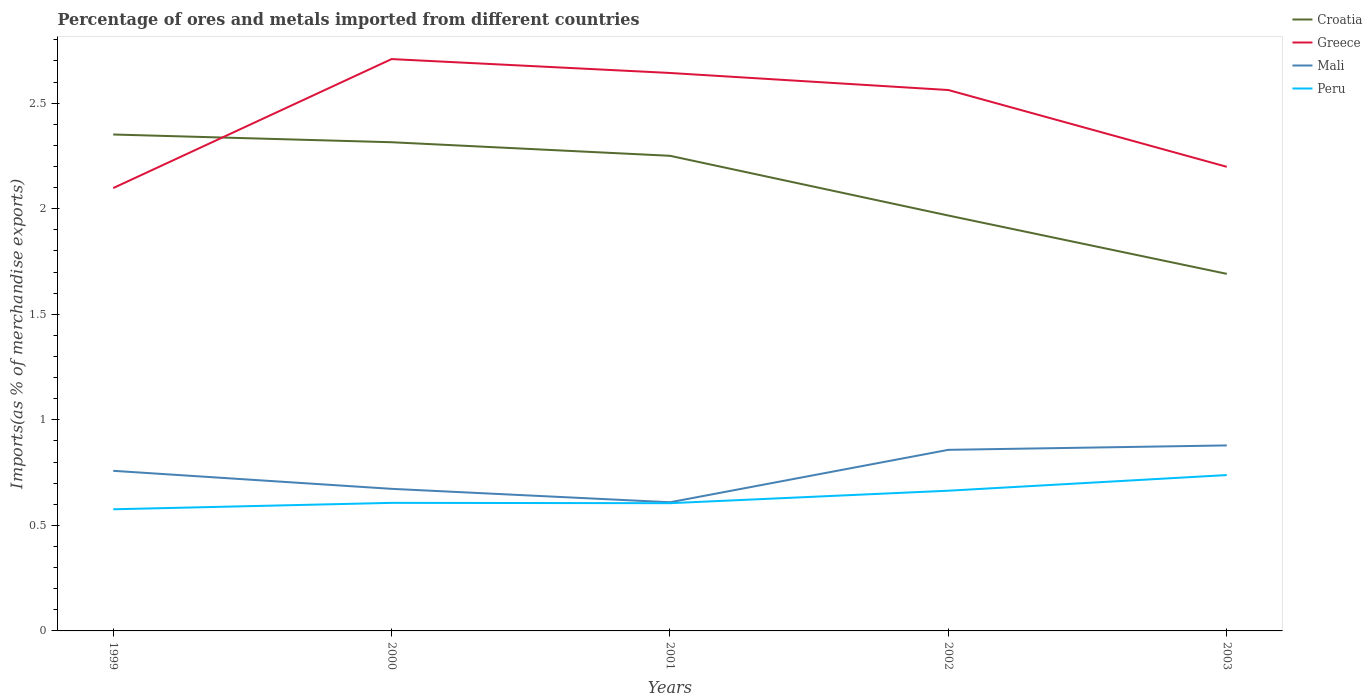Does the line corresponding to Peru intersect with the line corresponding to Mali?
Your answer should be very brief. No. Is the number of lines equal to the number of legend labels?
Make the answer very short. Yes. Across all years, what is the maximum percentage of imports to different countries in Croatia?
Provide a succinct answer. 1.69. In which year was the percentage of imports to different countries in Greece maximum?
Your response must be concise. 1999. What is the total percentage of imports to different countries in Croatia in the graph?
Provide a short and direct response. 0.56. What is the difference between the highest and the second highest percentage of imports to different countries in Mali?
Your response must be concise. 0.27. What is the difference between the highest and the lowest percentage of imports to different countries in Peru?
Offer a very short reply. 2. What is the difference between two consecutive major ticks on the Y-axis?
Ensure brevity in your answer.  0.5. Does the graph contain grids?
Ensure brevity in your answer.  No. How many legend labels are there?
Offer a very short reply. 4. What is the title of the graph?
Provide a succinct answer. Percentage of ores and metals imported from different countries. What is the label or title of the Y-axis?
Provide a succinct answer. Imports(as % of merchandise exports). What is the Imports(as % of merchandise exports) in Croatia in 1999?
Offer a terse response. 2.35. What is the Imports(as % of merchandise exports) of Greece in 1999?
Offer a terse response. 2.1. What is the Imports(as % of merchandise exports) in Mali in 1999?
Your answer should be very brief. 0.76. What is the Imports(as % of merchandise exports) in Peru in 1999?
Provide a succinct answer. 0.58. What is the Imports(as % of merchandise exports) in Croatia in 2000?
Offer a terse response. 2.32. What is the Imports(as % of merchandise exports) of Greece in 2000?
Your answer should be compact. 2.71. What is the Imports(as % of merchandise exports) of Mali in 2000?
Give a very brief answer. 0.67. What is the Imports(as % of merchandise exports) of Peru in 2000?
Your answer should be compact. 0.61. What is the Imports(as % of merchandise exports) in Croatia in 2001?
Provide a succinct answer. 2.25. What is the Imports(as % of merchandise exports) in Greece in 2001?
Your response must be concise. 2.64. What is the Imports(as % of merchandise exports) in Mali in 2001?
Give a very brief answer. 0.61. What is the Imports(as % of merchandise exports) of Peru in 2001?
Your answer should be compact. 0.61. What is the Imports(as % of merchandise exports) of Croatia in 2002?
Give a very brief answer. 1.97. What is the Imports(as % of merchandise exports) of Greece in 2002?
Make the answer very short. 2.56. What is the Imports(as % of merchandise exports) in Mali in 2002?
Offer a terse response. 0.86. What is the Imports(as % of merchandise exports) of Peru in 2002?
Make the answer very short. 0.66. What is the Imports(as % of merchandise exports) of Croatia in 2003?
Your answer should be compact. 1.69. What is the Imports(as % of merchandise exports) in Greece in 2003?
Keep it short and to the point. 2.2. What is the Imports(as % of merchandise exports) in Mali in 2003?
Keep it short and to the point. 0.88. What is the Imports(as % of merchandise exports) of Peru in 2003?
Give a very brief answer. 0.74. Across all years, what is the maximum Imports(as % of merchandise exports) in Croatia?
Your answer should be very brief. 2.35. Across all years, what is the maximum Imports(as % of merchandise exports) in Greece?
Your answer should be compact. 2.71. Across all years, what is the maximum Imports(as % of merchandise exports) in Mali?
Provide a short and direct response. 0.88. Across all years, what is the maximum Imports(as % of merchandise exports) of Peru?
Give a very brief answer. 0.74. Across all years, what is the minimum Imports(as % of merchandise exports) in Croatia?
Your answer should be compact. 1.69. Across all years, what is the minimum Imports(as % of merchandise exports) of Greece?
Your answer should be very brief. 2.1. Across all years, what is the minimum Imports(as % of merchandise exports) in Mali?
Provide a short and direct response. 0.61. Across all years, what is the minimum Imports(as % of merchandise exports) in Peru?
Your answer should be compact. 0.58. What is the total Imports(as % of merchandise exports) of Croatia in the graph?
Offer a terse response. 10.58. What is the total Imports(as % of merchandise exports) of Greece in the graph?
Provide a succinct answer. 12.21. What is the total Imports(as % of merchandise exports) of Mali in the graph?
Provide a short and direct response. 3.78. What is the total Imports(as % of merchandise exports) in Peru in the graph?
Your response must be concise. 3.19. What is the difference between the Imports(as % of merchandise exports) of Croatia in 1999 and that in 2000?
Your response must be concise. 0.04. What is the difference between the Imports(as % of merchandise exports) of Greece in 1999 and that in 2000?
Provide a short and direct response. -0.61. What is the difference between the Imports(as % of merchandise exports) in Mali in 1999 and that in 2000?
Provide a succinct answer. 0.09. What is the difference between the Imports(as % of merchandise exports) in Peru in 1999 and that in 2000?
Make the answer very short. -0.03. What is the difference between the Imports(as % of merchandise exports) of Croatia in 1999 and that in 2001?
Provide a short and direct response. 0.1. What is the difference between the Imports(as % of merchandise exports) in Greece in 1999 and that in 2001?
Ensure brevity in your answer.  -0.55. What is the difference between the Imports(as % of merchandise exports) in Mali in 1999 and that in 2001?
Offer a terse response. 0.15. What is the difference between the Imports(as % of merchandise exports) of Peru in 1999 and that in 2001?
Give a very brief answer. -0.03. What is the difference between the Imports(as % of merchandise exports) in Croatia in 1999 and that in 2002?
Your response must be concise. 0.38. What is the difference between the Imports(as % of merchandise exports) of Greece in 1999 and that in 2002?
Provide a short and direct response. -0.46. What is the difference between the Imports(as % of merchandise exports) of Mali in 1999 and that in 2002?
Offer a very short reply. -0.1. What is the difference between the Imports(as % of merchandise exports) of Peru in 1999 and that in 2002?
Your answer should be very brief. -0.09. What is the difference between the Imports(as % of merchandise exports) of Croatia in 1999 and that in 2003?
Offer a terse response. 0.66. What is the difference between the Imports(as % of merchandise exports) of Greece in 1999 and that in 2003?
Give a very brief answer. -0.1. What is the difference between the Imports(as % of merchandise exports) in Mali in 1999 and that in 2003?
Provide a short and direct response. -0.12. What is the difference between the Imports(as % of merchandise exports) in Peru in 1999 and that in 2003?
Give a very brief answer. -0.16. What is the difference between the Imports(as % of merchandise exports) of Croatia in 2000 and that in 2001?
Your answer should be very brief. 0.06. What is the difference between the Imports(as % of merchandise exports) of Greece in 2000 and that in 2001?
Your answer should be compact. 0.07. What is the difference between the Imports(as % of merchandise exports) of Mali in 2000 and that in 2001?
Give a very brief answer. 0.06. What is the difference between the Imports(as % of merchandise exports) in Peru in 2000 and that in 2001?
Offer a terse response. 0. What is the difference between the Imports(as % of merchandise exports) of Croatia in 2000 and that in 2002?
Your answer should be compact. 0.35. What is the difference between the Imports(as % of merchandise exports) of Greece in 2000 and that in 2002?
Offer a very short reply. 0.15. What is the difference between the Imports(as % of merchandise exports) in Mali in 2000 and that in 2002?
Your answer should be very brief. -0.18. What is the difference between the Imports(as % of merchandise exports) in Peru in 2000 and that in 2002?
Provide a succinct answer. -0.06. What is the difference between the Imports(as % of merchandise exports) of Croatia in 2000 and that in 2003?
Ensure brevity in your answer.  0.62. What is the difference between the Imports(as % of merchandise exports) of Greece in 2000 and that in 2003?
Your response must be concise. 0.51. What is the difference between the Imports(as % of merchandise exports) of Mali in 2000 and that in 2003?
Give a very brief answer. -0.21. What is the difference between the Imports(as % of merchandise exports) of Peru in 2000 and that in 2003?
Ensure brevity in your answer.  -0.13. What is the difference between the Imports(as % of merchandise exports) in Croatia in 2001 and that in 2002?
Make the answer very short. 0.28. What is the difference between the Imports(as % of merchandise exports) of Greece in 2001 and that in 2002?
Provide a short and direct response. 0.08. What is the difference between the Imports(as % of merchandise exports) in Mali in 2001 and that in 2002?
Provide a succinct answer. -0.25. What is the difference between the Imports(as % of merchandise exports) in Peru in 2001 and that in 2002?
Provide a succinct answer. -0.06. What is the difference between the Imports(as % of merchandise exports) of Croatia in 2001 and that in 2003?
Offer a terse response. 0.56. What is the difference between the Imports(as % of merchandise exports) in Greece in 2001 and that in 2003?
Your answer should be compact. 0.44. What is the difference between the Imports(as % of merchandise exports) in Mali in 2001 and that in 2003?
Offer a very short reply. -0.27. What is the difference between the Imports(as % of merchandise exports) in Peru in 2001 and that in 2003?
Your answer should be compact. -0.13. What is the difference between the Imports(as % of merchandise exports) of Croatia in 2002 and that in 2003?
Make the answer very short. 0.28. What is the difference between the Imports(as % of merchandise exports) of Greece in 2002 and that in 2003?
Your answer should be very brief. 0.36. What is the difference between the Imports(as % of merchandise exports) in Mali in 2002 and that in 2003?
Provide a succinct answer. -0.02. What is the difference between the Imports(as % of merchandise exports) in Peru in 2002 and that in 2003?
Offer a very short reply. -0.07. What is the difference between the Imports(as % of merchandise exports) of Croatia in 1999 and the Imports(as % of merchandise exports) of Greece in 2000?
Offer a very short reply. -0.36. What is the difference between the Imports(as % of merchandise exports) of Croatia in 1999 and the Imports(as % of merchandise exports) of Mali in 2000?
Your response must be concise. 1.68. What is the difference between the Imports(as % of merchandise exports) in Croatia in 1999 and the Imports(as % of merchandise exports) in Peru in 2000?
Make the answer very short. 1.75. What is the difference between the Imports(as % of merchandise exports) of Greece in 1999 and the Imports(as % of merchandise exports) of Mali in 2000?
Ensure brevity in your answer.  1.42. What is the difference between the Imports(as % of merchandise exports) of Greece in 1999 and the Imports(as % of merchandise exports) of Peru in 2000?
Your answer should be compact. 1.49. What is the difference between the Imports(as % of merchandise exports) of Mali in 1999 and the Imports(as % of merchandise exports) of Peru in 2000?
Offer a terse response. 0.15. What is the difference between the Imports(as % of merchandise exports) of Croatia in 1999 and the Imports(as % of merchandise exports) of Greece in 2001?
Make the answer very short. -0.29. What is the difference between the Imports(as % of merchandise exports) in Croatia in 1999 and the Imports(as % of merchandise exports) in Mali in 2001?
Make the answer very short. 1.74. What is the difference between the Imports(as % of merchandise exports) in Croatia in 1999 and the Imports(as % of merchandise exports) in Peru in 2001?
Give a very brief answer. 1.75. What is the difference between the Imports(as % of merchandise exports) of Greece in 1999 and the Imports(as % of merchandise exports) of Mali in 2001?
Offer a very short reply. 1.49. What is the difference between the Imports(as % of merchandise exports) in Greece in 1999 and the Imports(as % of merchandise exports) in Peru in 2001?
Provide a succinct answer. 1.49. What is the difference between the Imports(as % of merchandise exports) in Mali in 1999 and the Imports(as % of merchandise exports) in Peru in 2001?
Your answer should be very brief. 0.15. What is the difference between the Imports(as % of merchandise exports) in Croatia in 1999 and the Imports(as % of merchandise exports) in Greece in 2002?
Offer a terse response. -0.21. What is the difference between the Imports(as % of merchandise exports) of Croatia in 1999 and the Imports(as % of merchandise exports) of Mali in 2002?
Give a very brief answer. 1.49. What is the difference between the Imports(as % of merchandise exports) in Croatia in 1999 and the Imports(as % of merchandise exports) in Peru in 2002?
Your answer should be very brief. 1.69. What is the difference between the Imports(as % of merchandise exports) in Greece in 1999 and the Imports(as % of merchandise exports) in Mali in 2002?
Offer a terse response. 1.24. What is the difference between the Imports(as % of merchandise exports) in Greece in 1999 and the Imports(as % of merchandise exports) in Peru in 2002?
Give a very brief answer. 1.43. What is the difference between the Imports(as % of merchandise exports) of Mali in 1999 and the Imports(as % of merchandise exports) of Peru in 2002?
Your response must be concise. 0.09. What is the difference between the Imports(as % of merchandise exports) of Croatia in 1999 and the Imports(as % of merchandise exports) of Greece in 2003?
Give a very brief answer. 0.15. What is the difference between the Imports(as % of merchandise exports) of Croatia in 1999 and the Imports(as % of merchandise exports) of Mali in 2003?
Make the answer very short. 1.47. What is the difference between the Imports(as % of merchandise exports) of Croatia in 1999 and the Imports(as % of merchandise exports) of Peru in 2003?
Provide a short and direct response. 1.61. What is the difference between the Imports(as % of merchandise exports) in Greece in 1999 and the Imports(as % of merchandise exports) in Mali in 2003?
Ensure brevity in your answer.  1.22. What is the difference between the Imports(as % of merchandise exports) in Greece in 1999 and the Imports(as % of merchandise exports) in Peru in 2003?
Your answer should be compact. 1.36. What is the difference between the Imports(as % of merchandise exports) in Mali in 1999 and the Imports(as % of merchandise exports) in Peru in 2003?
Your answer should be very brief. 0.02. What is the difference between the Imports(as % of merchandise exports) of Croatia in 2000 and the Imports(as % of merchandise exports) of Greece in 2001?
Offer a terse response. -0.33. What is the difference between the Imports(as % of merchandise exports) in Croatia in 2000 and the Imports(as % of merchandise exports) in Mali in 2001?
Offer a very short reply. 1.71. What is the difference between the Imports(as % of merchandise exports) in Croatia in 2000 and the Imports(as % of merchandise exports) in Peru in 2001?
Your response must be concise. 1.71. What is the difference between the Imports(as % of merchandise exports) of Greece in 2000 and the Imports(as % of merchandise exports) of Mali in 2001?
Make the answer very short. 2.1. What is the difference between the Imports(as % of merchandise exports) of Greece in 2000 and the Imports(as % of merchandise exports) of Peru in 2001?
Make the answer very short. 2.1. What is the difference between the Imports(as % of merchandise exports) in Mali in 2000 and the Imports(as % of merchandise exports) in Peru in 2001?
Keep it short and to the point. 0.07. What is the difference between the Imports(as % of merchandise exports) of Croatia in 2000 and the Imports(as % of merchandise exports) of Greece in 2002?
Your response must be concise. -0.25. What is the difference between the Imports(as % of merchandise exports) of Croatia in 2000 and the Imports(as % of merchandise exports) of Mali in 2002?
Give a very brief answer. 1.46. What is the difference between the Imports(as % of merchandise exports) of Croatia in 2000 and the Imports(as % of merchandise exports) of Peru in 2002?
Offer a terse response. 1.65. What is the difference between the Imports(as % of merchandise exports) in Greece in 2000 and the Imports(as % of merchandise exports) in Mali in 2002?
Offer a very short reply. 1.85. What is the difference between the Imports(as % of merchandise exports) of Greece in 2000 and the Imports(as % of merchandise exports) of Peru in 2002?
Keep it short and to the point. 2.04. What is the difference between the Imports(as % of merchandise exports) of Mali in 2000 and the Imports(as % of merchandise exports) of Peru in 2002?
Make the answer very short. 0.01. What is the difference between the Imports(as % of merchandise exports) in Croatia in 2000 and the Imports(as % of merchandise exports) in Greece in 2003?
Provide a short and direct response. 0.12. What is the difference between the Imports(as % of merchandise exports) of Croatia in 2000 and the Imports(as % of merchandise exports) of Mali in 2003?
Ensure brevity in your answer.  1.44. What is the difference between the Imports(as % of merchandise exports) in Croatia in 2000 and the Imports(as % of merchandise exports) in Peru in 2003?
Your answer should be very brief. 1.58. What is the difference between the Imports(as % of merchandise exports) of Greece in 2000 and the Imports(as % of merchandise exports) of Mali in 2003?
Make the answer very short. 1.83. What is the difference between the Imports(as % of merchandise exports) in Greece in 2000 and the Imports(as % of merchandise exports) in Peru in 2003?
Your answer should be very brief. 1.97. What is the difference between the Imports(as % of merchandise exports) of Mali in 2000 and the Imports(as % of merchandise exports) of Peru in 2003?
Your response must be concise. -0.07. What is the difference between the Imports(as % of merchandise exports) of Croatia in 2001 and the Imports(as % of merchandise exports) of Greece in 2002?
Provide a short and direct response. -0.31. What is the difference between the Imports(as % of merchandise exports) in Croatia in 2001 and the Imports(as % of merchandise exports) in Mali in 2002?
Your answer should be compact. 1.39. What is the difference between the Imports(as % of merchandise exports) in Croatia in 2001 and the Imports(as % of merchandise exports) in Peru in 2002?
Give a very brief answer. 1.59. What is the difference between the Imports(as % of merchandise exports) in Greece in 2001 and the Imports(as % of merchandise exports) in Mali in 2002?
Provide a short and direct response. 1.79. What is the difference between the Imports(as % of merchandise exports) of Greece in 2001 and the Imports(as % of merchandise exports) of Peru in 2002?
Your answer should be very brief. 1.98. What is the difference between the Imports(as % of merchandise exports) in Mali in 2001 and the Imports(as % of merchandise exports) in Peru in 2002?
Offer a very short reply. -0.05. What is the difference between the Imports(as % of merchandise exports) in Croatia in 2001 and the Imports(as % of merchandise exports) in Greece in 2003?
Your answer should be compact. 0.05. What is the difference between the Imports(as % of merchandise exports) in Croatia in 2001 and the Imports(as % of merchandise exports) in Mali in 2003?
Give a very brief answer. 1.37. What is the difference between the Imports(as % of merchandise exports) of Croatia in 2001 and the Imports(as % of merchandise exports) of Peru in 2003?
Your answer should be compact. 1.51. What is the difference between the Imports(as % of merchandise exports) of Greece in 2001 and the Imports(as % of merchandise exports) of Mali in 2003?
Keep it short and to the point. 1.76. What is the difference between the Imports(as % of merchandise exports) in Greece in 2001 and the Imports(as % of merchandise exports) in Peru in 2003?
Provide a succinct answer. 1.9. What is the difference between the Imports(as % of merchandise exports) of Mali in 2001 and the Imports(as % of merchandise exports) of Peru in 2003?
Provide a short and direct response. -0.13. What is the difference between the Imports(as % of merchandise exports) of Croatia in 2002 and the Imports(as % of merchandise exports) of Greece in 2003?
Your answer should be compact. -0.23. What is the difference between the Imports(as % of merchandise exports) in Croatia in 2002 and the Imports(as % of merchandise exports) in Mali in 2003?
Your answer should be very brief. 1.09. What is the difference between the Imports(as % of merchandise exports) in Croatia in 2002 and the Imports(as % of merchandise exports) in Peru in 2003?
Ensure brevity in your answer.  1.23. What is the difference between the Imports(as % of merchandise exports) of Greece in 2002 and the Imports(as % of merchandise exports) of Mali in 2003?
Keep it short and to the point. 1.68. What is the difference between the Imports(as % of merchandise exports) in Greece in 2002 and the Imports(as % of merchandise exports) in Peru in 2003?
Give a very brief answer. 1.82. What is the difference between the Imports(as % of merchandise exports) in Mali in 2002 and the Imports(as % of merchandise exports) in Peru in 2003?
Your answer should be compact. 0.12. What is the average Imports(as % of merchandise exports) in Croatia per year?
Give a very brief answer. 2.12. What is the average Imports(as % of merchandise exports) in Greece per year?
Your response must be concise. 2.44. What is the average Imports(as % of merchandise exports) in Mali per year?
Your answer should be very brief. 0.76. What is the average Imports(as % of merchandise exports) of Peru per year?
Ensure brevity in your answer.  0.64. In the year 1999, what is the difference between the Imports(as % of merchandise exports) of Croatia and Imports(as % of merchandise exports) of Greece?
Provide a succinct answer. 0.25. In the year 1999, what is the difference between the Imports(as % of merchandise exports) of Croatia and Imports(as % of merchandise exports) of Mali?
Your response must be concise. 1.59. In the year 1999, what is the difference between the Imports(as % of merchandise exports) of Croatia and Imports(as % of merchandise exports) of Peru?
Your response must be concise. 1.78. In the year 1999, what is the difference between the Imports(as % of merchandise exports) of Greece and Imports(as % of merchandise exports) of Mali?
Keep it short and to the point. 1.34. In the year 1999, what is the difference between the Imports(as % of merchandise exports) of Greece and Imports(as % of merchandise exports) of Peru?
Give a very brief answer. 1.52. In the year 1999, what is the difference between the Imports(as % of merchandise exports) in Mali and Imports(as % of merchandise exports) in Peru?
Offer a very short reply. 0.18. In the year 2000, what is the difference between the Imports(as % of merchandise exports) in Croatia and Imports(as % of merchandise exports) in Greece?
Make the answer very short. -0.39. In the year 2000, what is the difference between the Imports(as % of merchandise exports) of Croatia and Imports(as % of merchandise exports) of Mali?
Ensure brevity in your answer.  1.64. In the year 2000, what is the difference between the Imports(as % of merchandise exports) in Croatia and Imports(as % of merchandise exports) in Peru?
Your answer should be compact. 1.71. In the year 2000, what is the difference between the Imports(as % of merchandise exports) in Greece and Imports(as % of merchandise exports) in Mali?
Offer a very short reply. 2.04. In the year 2000, what is the difference between the Imports(as % of merchandise exports) of Greece and Imports(as % of merchandise exports) of Peru?
Offer a terse response. 2.1. In the year 2000, what is the difference between the Imports(as % of merchandise exports) of Mali and Imports(as % of merchandise exports) of Peru?
Offer a terse response. 0.07. In the year 2001, what is the difference between the Imports(as % of merchandise exports) of Croatia and Imports(as % of merchandise exports) of Greece?
Your answer should be very brief. -0.39. In the year 2001, what is the difference between the Imports(as % of merchandise exports) in Croatia and Imports(as % of merchandise exports) in Mali?
Your answer should be compact. 1.64. In the year 2001, what is the difference between the Imports(as % of merchandise exports) of Croatia and Imports(as % of merchandise exports) of Peru?
Provide a short and direct response. 1.65. In the year 2001, what is the difference between the Imports(as % of merchandise exports) of Greece and Imports(as % of merchandise exports) of Mali?
Make the answer very short. 2.03. In the year 2001, what is the difference between the Imports(as % of merchandise exports) of Greece and Imports(as % of merchandise exports) of Peru?
Your response must be concise. 2.04. In the year 2001, what is the difference between the Imports(as % of merchandise exports) in Mali and Imports(as % of merchandise exports) in Peru?
Ensure brevity in your answer.  0. In the year 2002, what is the difference between the Imports(as % of merchandise exports) in Croatia and Imports(as % of merchandise exports) in Greece?
Your response must be concise. -0.59. In the year 2002, what is the difference between the Imports(as % of merchandise exports) in Croatia and Imports(as % of merchandise exports) in Mali?
Provide a short and direct response. 1.11. In the year 2002, what is the difference between the Imports(as % of merchandise exports) in Croatia and Imports(as % of merchandise exports) in Peru?
Ensure brevity in your answer.  1.3. In the year 2002, what is the difference between the Imports(as % of merchandise exports) in Greece and Imports(as % of merchandise exports) in Mali?
Offer a very short reply. 1.7. In the year 2002, what is the difference between the Imports(as % of merchandise exports) in Greece and Imports(as % of merchandise exports) in Peru?
Your response must be concise. 1.9. In the year 2002, what is the difference between the Imports(as % of merchandise exports) of Mali and Imports(as % of merchandise exports) of Peru?
Offer a terse response. 0.19. In the year 2003, what is the difference between the Imports(as % of merchandise exports) in Croatia and Imports(as % of merchandise exports) in Greece?
Offer a terse response. -0.51. In the year 2003, what is the difference between the Imports(as % of merchandise exports) of Croatia and Imports(as % of merchandise exports) of Mali?
Give a very brief answer. 0.81. In the year 2003, what is the difference between the Imports(as % of merchandise exports) in Croatia and Imports(as % of merchandise exports) in Peru?
Provide a succinct answer. 0.95. In the year 2003, what is the difference between the Imports(as % of merchandise exports) in Greece and Imports(as % of merchandise exports) in Mali?
Ensure brevity in your answer.  1.32. In the year 2003, what is the difference between the Imports(as % of merchandise exports) in Greece and Imports(as % of merchandise exports) in Peru?
Offer a terse response. 1.46. In the year 2003, what is the difference between the Imports(as % of merchandise exports) in Mali and Imports(as % of merchandise exports) in Peru?
Offer a terse response. 0.14. What is the ratio of the Imports(as % of merchandise exports) of Croatia in 1999 to that in 2000?
Your response must be concise. 1.02. What is the ratio of the Imports(as % of merchandise exports) in Greece in 1999 to that in 2000?
Your answer should be compact. 0.77. What is the ratio of the Imports(as % of merchandise exports) in Mali in 1999 to that in 2000?
Offer a terse response. 1.13. What is the ratio of the Imports(as % of merchandise exports) in Peru in 1999 to that in 2000?
Ensure brevity in your answer.  0.95. What is the ratio of the Imports(as % of merchandise exports) of Croatia in 1999 to that in 2001?
Your response must be concise. 1.04. What is the ratio of the Imports(as % of merchandise exports) of Greece in 1999 to that in 2001?
Ensure brevity in your answer.  0.79. What is the ratio of the Imports(as % of merchandise exports) of Mali in 1999 to that in 2001?
Make the answer very short. 1.24. What is the ratio of the Imports(as % of merchandise exports) in Peru in 1999 to that in 2001?
Provide a short and direct response. 0.95. What is the ratio of the Imports(as % of merchandise exports) of Croatia in 1999 to that in 2002?
Your response must be concise. 1.2. What is the ratio of the Imports(as % of merchandise exports) in Greece in 1999 to that in 2002?
Offer a very short reply. 0.82. What is the ratio of the Imports(as % of merchandise exports) in Mali in 1999 to that in 2002?
Make the answer very short. 0.88. What is the ratio of the Imports(as % of merchandise exports) in Peru in 1999 to that in 2002?
Give a very brief answer. 0.87. What is the ratio of the Imports(as % of merchandise exports) of Croatia in 1999 to that in 2003?
Your answer should be compact. 1.39. What is the ratio of the Imports(as % of merchandise exports) of Greece in 1999 to that in 2003?
Your response must be concise. 0.95. What is the ratio of the Imports(as % of merchandise exports) in Mali in 1999 to that in 2003?
Provide a succinct answer. 0.86. What is the ratio of the Imports(as % of merchandise exports) in Peru in 1999 to that in 2003?
Your answer should be very brief. 0.78. What is the ratio of the Imports(as % of merchandise exports) of Croatia in 2000 to that in 2001?
Provide a succinct answer. 1.03. What is the ratio of the Imports(as % of merchandise exports) of Greece in 2000 to that in 2001?
Keep it short and to the point. 1.02. What is the ratio of the Imports(as % of merchandise exports) in Mali in 2000 to that in 2001?
Your response must be concise. 1.1. What is the ratio of the Imports(as % of merchandise exports) of Croatia in 2000 to that in 2002?
Offer a very short reply. 1.18. What is the ratio of the Imports(as % of merchandise exports) of Greece in 2000 to that in 2002?
Provide a short and direct response. 1.06. What is the ratio of the Imports(as % of merchandise exports) in Mali in 2000 to that in 2002?
Give a very brief answer. 0.78. What is the ratio of the Imports(as % of merchandise exports) in Peru in 2000 to that in 2002?
Give a very brief answer. 0.91. What is the ratio of the Imports(as % of merchandise exports) of Croatia in 2000 to that in 2003?
Your response must be concise. 1.37. What is the ratio of the Imports(as % of merchandise exports) of Greece in 2000 to that in 2003?
Your response must be concise. 1.23. What is the ratio of the Imports(as % of merchandise exports) in Mali in 2000 to that in 2003?
Provide a succinct answer. 0.77. What is the ratio of the Imports(as % of merchandise exports) in Peru in 2000 to that in 2003?
Your response must be concise. 0.82. What is the ratio of the Imports(as % of merchandise exports) of Croatia in 2001 to that in 2002?
Your response must be concise. 1.14. What is the ratio of the Imports(as % of merchandise exports) of Greece in 2001 to that in 2002?
Provide a short and direct response. 1.03. What is the ratio of the Imports(as % of merchandise exports) of Mali in 2001 to that in 2002?
Keep it short and to the point. 0.71. What is the ratio of the Imports(as % of merchandise exports) of Peru in 2001 to that in 2002?
Make the answer very short. 0.91. What is the ratio of the Imports(as % of merchandise exports) in Croatia in 2001 to that in 2003?
Your answer should be compact. 1.33. What is the ratio of the Imports(as % of merchandise exports) in Greece in 2001 to that in 2003?
Your response must be concise. 1.2. What is the ratio of the Imports(as % of merchandise exports) in Mali in 2001 to that in 2003?
Offer a terse response. 0.69. What is the ratio of the Imports(as % of merchandise exports) in Peru in 2001 to that in 2003?
Make the answer very short. 0.82. What is the ratio of the Imports(as % of merchandise exports) of Croatia in 2002 to that in 2003?
Keep it short and to the point. 1.16. What is the ratio of the Imports(as % of merchandise exports) in Greece in 2002 to that in 2003?
Offer a very short reply. 1.17. What is the ratio of the Imports(as % of merchandise exports) of Mali in 2002 to that in 2003?
Offer a very short reply. 0.98. What is the ratio of the Imports(as % of merchandise exports) of Peru in 2002 to that in 2003?
Offer a very short reply. 0.9. What is the difference between the highest and the second highest Imports(as % of merchandise exports) of Croatia?
Offer a very short reply. 0.04. What is the difference between the highest and the second highest Imports(as % of merchandise exports) in Greece?
Provide a succinct answer. 0.07. What is the difference between the highest and the second highest Imports(as % of merchandise exports) of Mali?
Your answer should be very brief. 0.02. What is the difference between the highest and the second highest Imports(as % of merchandise exports) of Peru?
Make the answer very short. 0.07. What is the difference between the highest and the lowest Imports(as % of merchandise exports) of Croatia?
Provide a short and direct response. 0.66. What is the difference between the highest and the lowest Imports(as % of merchandise exports) in Greece?
Make the answer very short. 0.61. What is the difference between the highest and the lowest Imports(as % of merchandise exports) of Mali?
Your answer should be very brief. 0.27. What is the difference between the highest and the lowest Imports(as % of merchandise exports) in Peru?
Your response must be concise. 0.16. 